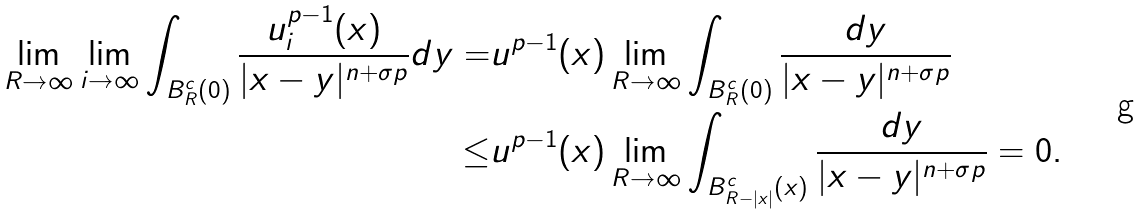<formula> <loc_0><loc_0><loc_500><loc_500>\lim _ { R \rightarrow \infty } \lim _ { i \rightarrow \infty } \int _ { B _ { R } ^ { c } ( 0 ) } \frac { u _ { i } ^ { p - 1 } ( x ) } { | x - y | ^ { n + \sigma p } } d y = & u ^ { p - 1 } ( x ) \lim _ { R \rightarrow \infty } \int _ { B _ { R } ^ { c } ( 0 ) } \frac { d y } { | x - y | ^ { n + \sigma p } } \\ \leq & u ^ { p - 1 } ( x ) \lim _ { R \rightarrow \infty } \int _ { B _ { R - | x | } ^ { c } ( x ) } \frac { d y } { | x - y | ^ { n + \sigma p } } = 0 .</formula> 